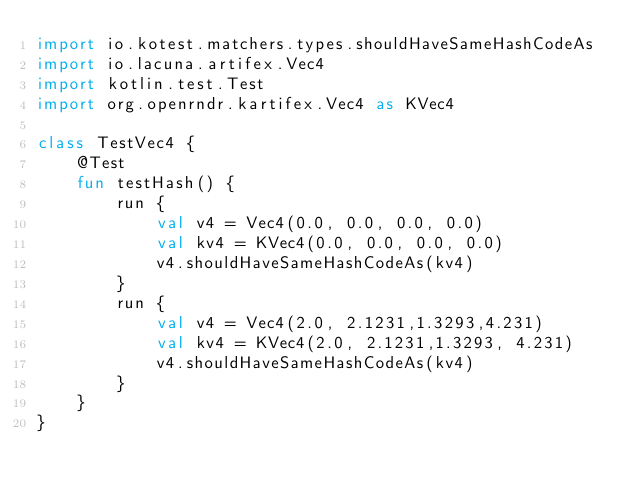<code> <loc_0><loc_0><loc_500><loc_500><_Kotlin_>import io.kotest.matchers.types.shouldHaveSameHashCodeAs
import io.lacuna.artifex.Vec4
import kotlin.test.Test
import org.openrndr.kartifex.Vec4 as KVec4

class TestVec4 {
    @Test
    fun testHash() {
        run {
            val v4 = Vec4(0.0, 0.0, 0.0, 0.0)
            val kv4 = KVec4(0.0, 0.0, 0.0, 0.0)
            v4.shouldHaveSameHashCodeAs(kv4)
        }
        run {
            val v4 = Vec4(2.0, 2.1231,1.3293,4.231)
            val kv4 = KVec4(2.0, 2.1231,1.3293, 4.231)
            v4.shouldHaveSameHashCodeAs(kv4)
        }
    }
}</code> 